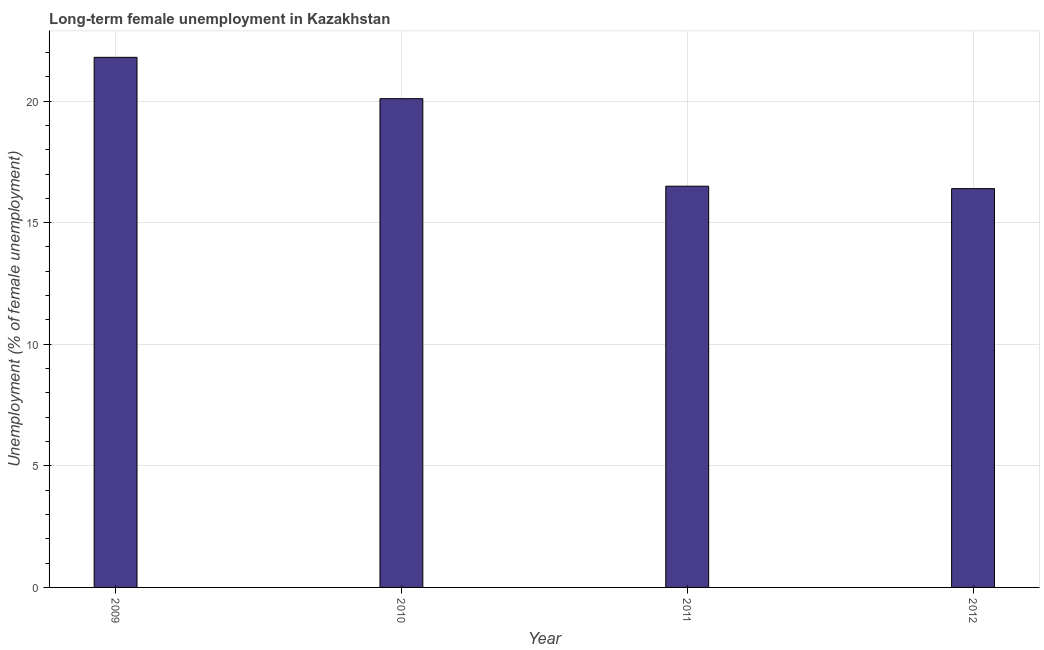Does the graph contain any zero values?
Make the answer very short. No. Does the graph contain grids?
Make the answer very short. Yes. What is the title of the graph?
Keep it short and to the point. Long-term female unemployment in Kazakhstan. What is the label or title of the Y-axis?
Your response must be concise. Unemployment (% of female unemployment). What is the long-term female unemployment in 2010?
Your answer should be very brief. 20.1. Across all years, what is the maximum long-term female unemployment?
Provide a short and direct response. 21.8. Across all years, what is the minimum long-term female unemployment?
Your answer should be very brief. 16.4. In which year was the long-term female unemployment minimum?
Give a very brief answer. 2012. What is the sum of the long-term female unemployment?
Keep it short and to the point. 74.8. What is the median long-term female unemployment?
Make the answer very short. 18.3. Do a majority of the years between 2011 and 2010 (inclusive) have long-term female unemployment greater than 21 %?
Offer a terse response. No. What is the ratio of the long-term female unemployment in 2010 to that in 2011?
Provide a succinct answer. 1.22. Is the difference between the long-term female unemployment in 2010 and 2012 greater than the difference between any two years?
Your response must be concise. No. What is the difference between the highest and the lowest long-term female unemployment?
Offer a terse response. 5.4. What is the difference between two consecutive major ticks on the Y-axis?
Make the answer very short. 5. What is the Unemployment (% of female unemployment) of 2009?
Give a very brief answer. 21.8. What is the Unemployment (% of female unemployment) of 2010?
Offer a very short reply. 20.1. What is the Unemployment (% of female unemployment) of 2011?
Offer a terse response. 16.5. What is the Unemployment (% of female unemployment) in 2012?
Your answer should be compact. 16.4. What is the difference between the Unemployment (% of female unemployment) in 2009 and 2011?
Offer a terse response. 5.3. What is the difference between the Unemployment (% of female unemployment) in 2009 and 2012?
Give a very brief answer. 5.4. What is the difference between the Unemployment (% of female unemployment) in 2010 and 2012?
Your answer should be compact. 3.7. What is the ratio of the Unemployment (% of female unemployment) in 2009 to that in 2010?
Offer a terse response. 1.08. What is the ratio of the Unemployment (% of female unemployment) in 2009 to that in 2011?
Your answer should be very brief. 1.32. What is the ratio of the Unemployment (% of female unemployment) in 2009 to that in 2012?
Provide a succinct answer. 1.33. What is the ratio of the Unemployment (% of female unemployment) in 2010 to that in 2011?
Ensure brevity in your answer.  1.22. What is the ratio of the Unemployment (% of female unemployment) in 2010 to that in 2012?
Make the answer very short. 1.23. 